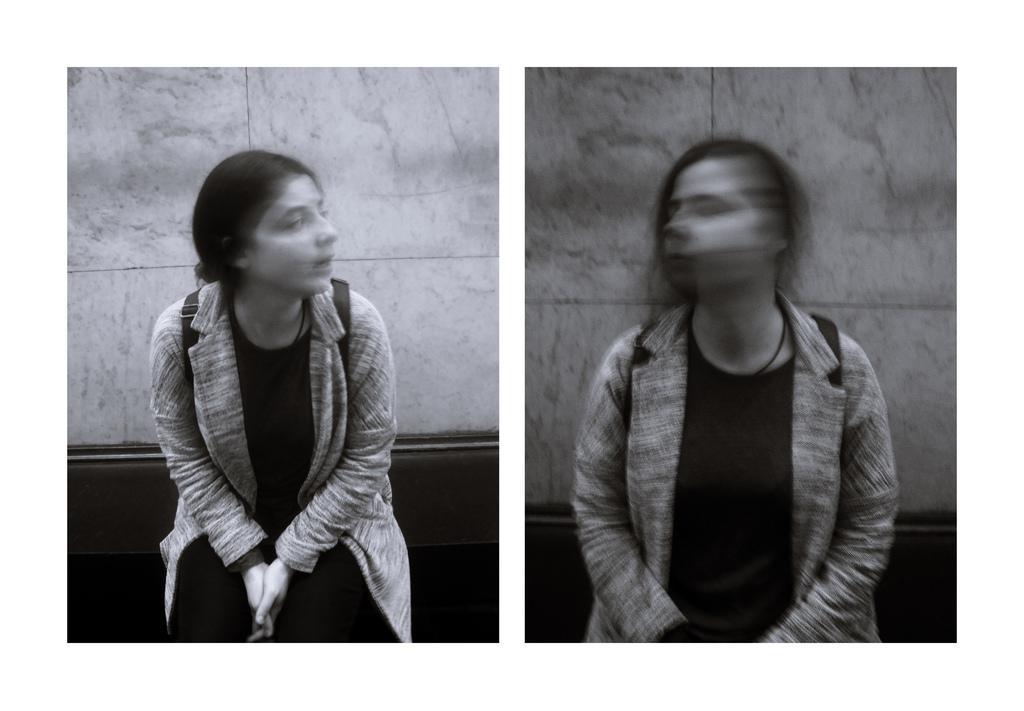In one or two sentences, can you explain what this image depicts? In this image, we can see the photocopies of a person. Among them, one of the photocopies is blurred. We can also see the background. 